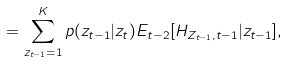Convert formula to latex. <formula><loc_0><loc_0><loc_500><loc_500>= \sum _ { z _ { t - 1 } = 1 } ^ { K } { p ( z _ { t - 1 } | z _ { t } ) E _ { t - 2 } [ H _ { Z _ { t - 1 } , t - 1 } | z _ { t - 1 } ] } ,</formula> 